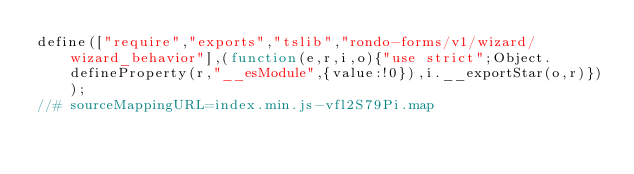<code> <loc_0><loc_0><loc_500><loc_500><_JavaScript_>define(["require","exports","tslib","rondo-forms/v1/wizard/wizard_behavior"],(function(e,r,i,o){"use strict";Object.defineProperty(r,"__esModule",{value:!0}),i.__exportStar(o,r)}));
//# sourceMappingURL=index.min.js-vfl2S79Pi.map</code> 